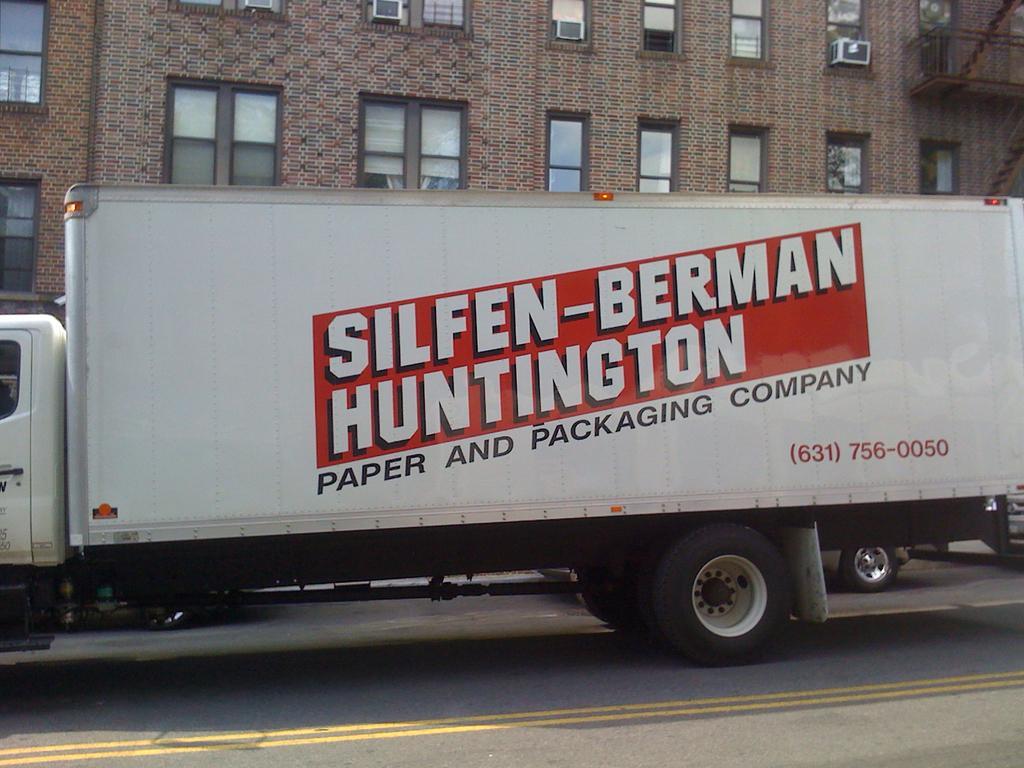Could you give a brief overview of what you see in this image? In this image we can see white color truck with some text on it is moving on the road. Here we can see another vehicle tires on the road. In the background, we can see the brick building with many glass windows, we can see air conditioner fans and the staircase. 